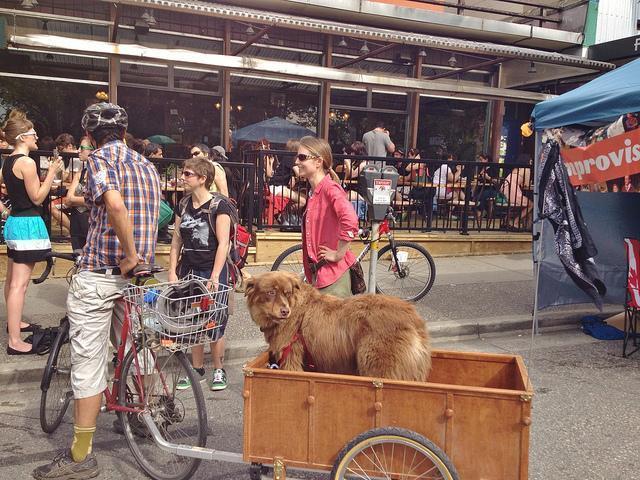What is the dog riding in?
Make your selection from the four choices given to correctly answer the question.
Options: Trolley, wagon, bus, car. Wagon. 